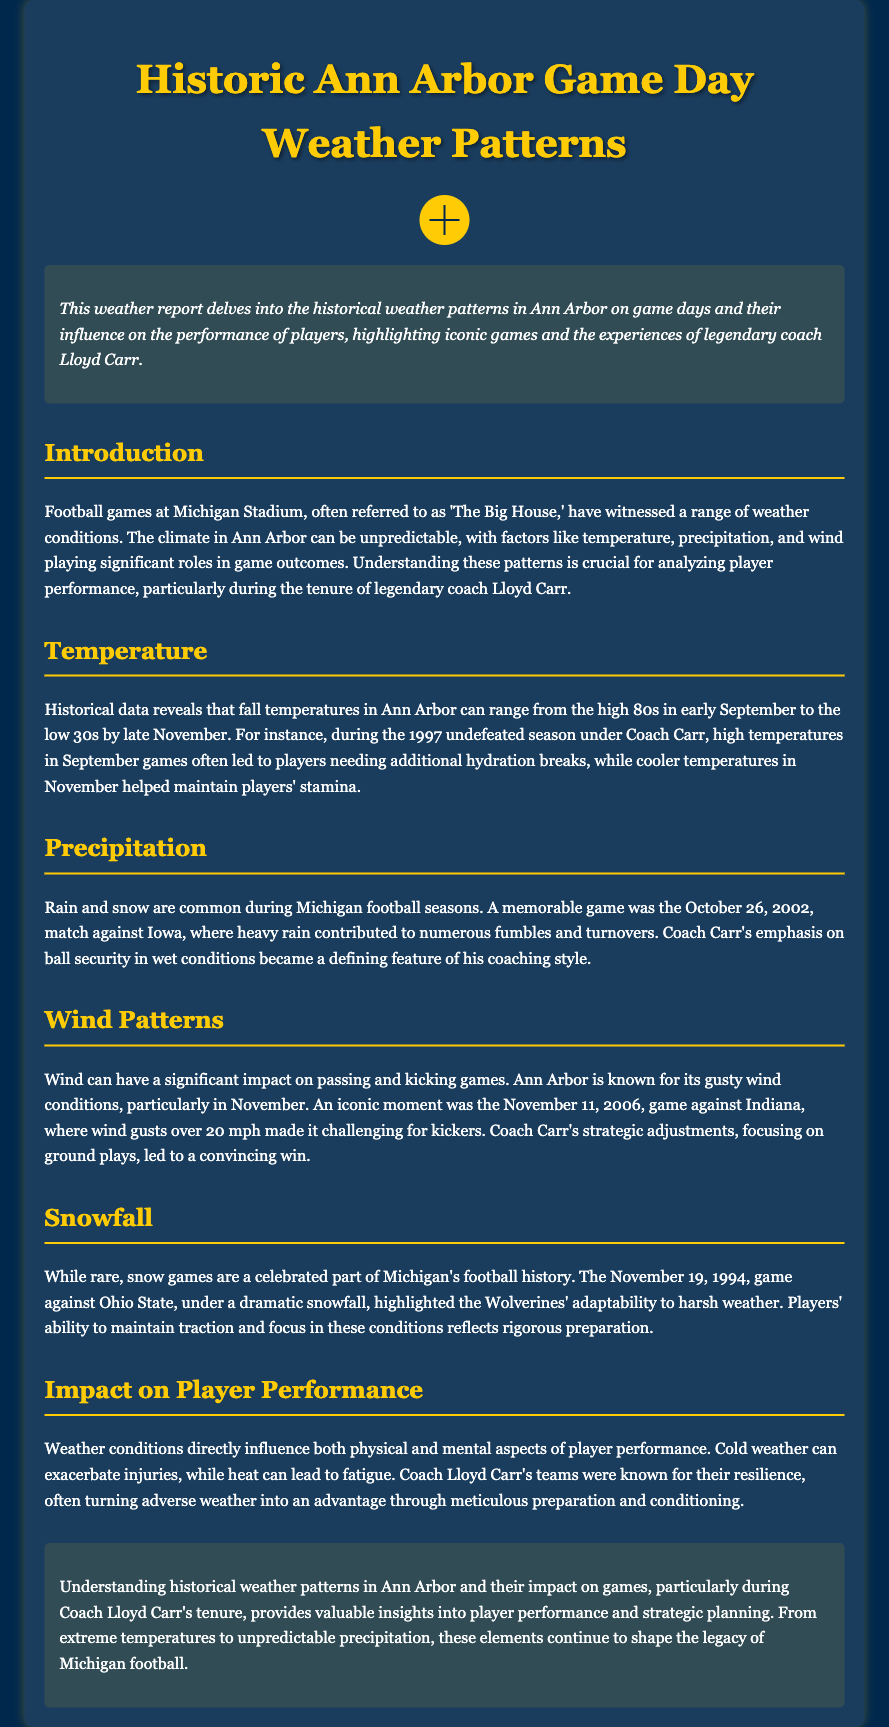what is the title of the document? The title is prominently displayed at the top of the document.
Answer: Historic Ann Arbor Game Day Weather Patterns what significant game occurred on October 26, 2002? The document mentions a memorable game in which weather impacted the outcome.
Answer: Iowa what is the range of fall temperatures mentioned? The document specifies the typical temperature range observed during fall seasons.
Answer: high 80s to low 30s which game is highlighted for its impact due to wind gusts? A specific game is noted where wind conditions significantly affected gameplay.
Answer: November 11, 2006 what coaching style aspect did Coach Carr emphasize during rainy conditions? The document describes a characteristic of Coach Carr's coaching during adverse weather.
Answer: ball security how does cold weather affect player performance according to the report? The report discusses the physical effects of cold weather on players.
Answer: exacerbate injuries what was the impact of snow as mentioned in the document? The document highlights a specific game showcasing player adaptability to snow conditions.
Answer: adaptability in what season did the Wolverines not lose a game under Coach Carr? The document refers to a specific season that was particularly successful for the team.
Answer: 1997 what weather condition is common during football seasons in Ann Arbor? The document describes the usual weather occurrences during the football season.
Answer: rain and snow 